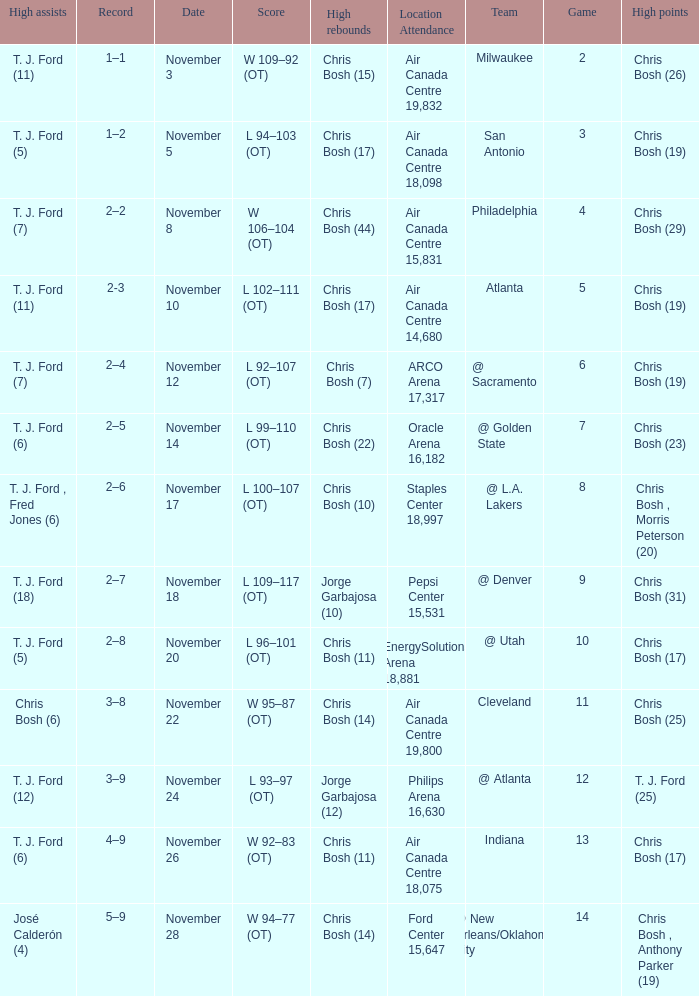Can you parse all the data within this table? {'header': ['High assists', 'Record', 'Date', 'Score', 'High rebounds', 'Location Attendance', 'Team', 'Game', 'High points'], 'rows': [['T. J. Ford (11)', '1–1', 'November 3', 'W 109–92 (OT)', 'Chris Bosh (15)', 'Air Canada Centre 19,832', 'Milwaukee', '2', 'Chris Bosh (26)'], ['T. J. Ford (5)', '1–2', 'November 5', 'L 94–103 (OT)', 'Chris Bosh (17)', 'Air Canada Centre 18,098', 'San Antonio', '3', 'Chris Bosh (19)'], ['T. J. Ford (7)', '2–2', 'November 8', 'W 106–104 (OT)', 'Chris Bosh (44)', 'Air Canada Centre 15,831', 'Philadelphia', '4', 'Chris Bosh (29)'], ['T. J. Ford (11)', '2-3', 'November 10', 'L 102–111 (OT)', 'Chris Bosh (17)', 'Air Canada Centre 14,680', 'Atlanta', '5', 'Chris Bosh (19)'], ['T. J. Ford (7)', '2–4', 'November 12', 'L 92–107 (OT)', 'Chris Bosh (7)', 'ARCO Arena 17,317', '@ Sacramento', '6', 'Chris Bosh (19)'], ['T. J. Ford (6)', '2–5', 'November 14', 'L 99–110 (OT)', 'Chris Bosh (22)', 'Oracle Arena 16,182', '@ Golden State', '7', 'Chris Bosh (23)'], ['T. J. Ford , Fred Jones (6)', '2–6', 'November 17', 'L 100–107 (OT)', 'Chris Bosh (10)', 'Staples Center 18,997', '@ L.A. Lakers', '8', 'Chris Bosh , Morris Peterson (20)'], ['T. J. Ford (18)', '2–7', 'November 18', 'L 109–117 (OT)', 'Jorge Garbajosa (10)', 'Pepsi Center 15,531', '@ Denver', '9', 'Chris Bosh (31)'], ['T. J. Ford (5)', '2–8', 'November 20', 'L 96–101 (OT)', 'Chris Bosh (11)', 'EnergySolutions Arena 18,881', '@ Utah', '10', 'Chris Bosh (17)'], ['Chris Bosh (6)', '3–8', 'November 22', 'W 95–87 (OT)', 'Chris Bosh (14)', 'Air Canada Centre 19,800', 'Cleveland', '11', 'Chris Bosh (25)'], ['T. J. Ford (12)', '3–9', 'November 24', 'L 93–97 (OT)', 'Jorge Garbajosa (12)', 'Philips Arena 16,630', '@ Atlanta', '12', 'T. J. Ford (25)'], ['T. J. Ford (6)', '4–9', 'November 26', 'W 92–83 (OT)', 'Chris Bosh (11)', 'Air Canada Centre 18,075', 'Indiana', '13', 'Chris Bosh (17)'], ['José Calderón (4)', '5–9', 'November 28', 'W 94–77 (OT)', 'Chris Bosh (14)', 'Ford Center 15,647', '@ New Orleans/Oklahoma City', '14', 'Chris Bosh , Anthony Parker (19)']]} Where was the game on November 20? EnergySolutions Arena 18,881. 